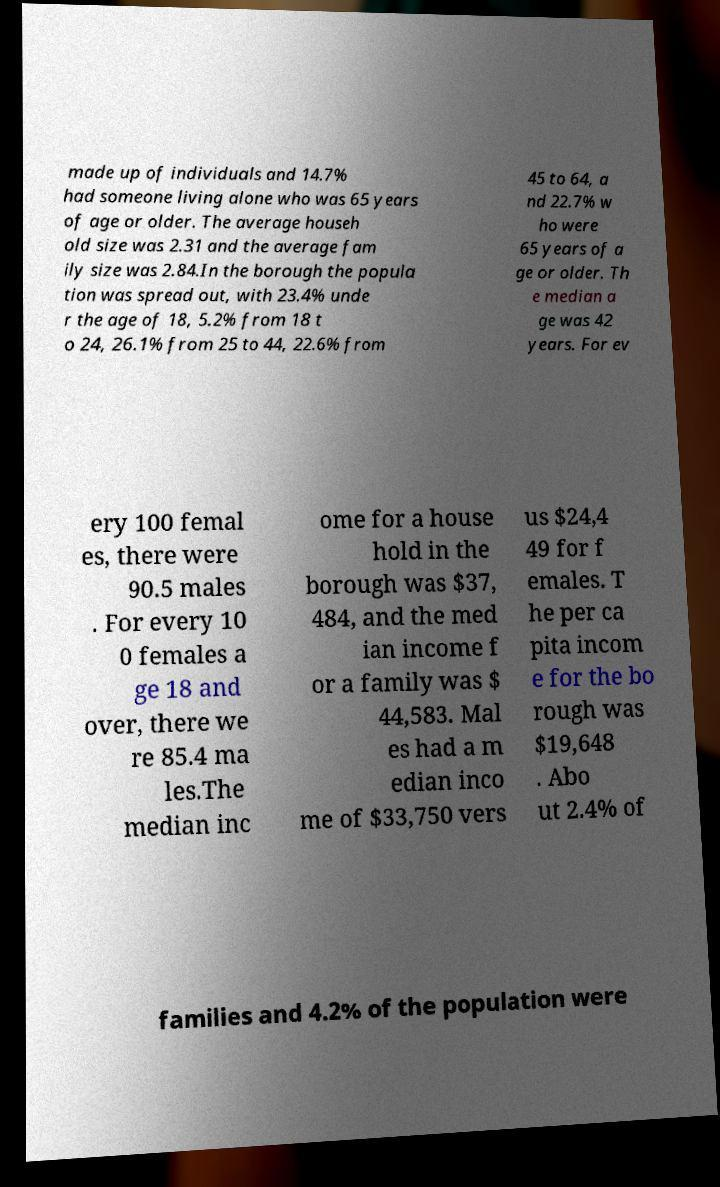Can you read and provide the text displayed in the image?This photo seems to have some interesting text. Can you extract and type it out for me? made up of individuals and 14.7% had someone living alone who was 65 years of age or older. The average househ old size was 2.31 and the average fam ily size was 2.84.In the borough the popula tion was spread out, with 23.4% unde r the age of 18, 5.2% from 18 t o 24, 26.1% from 25 to 44, 22.6% from 45 to 64, a nd 22.7% w ho were 65 years of a ge or older. Th e median a ge was 42 years. For ev ery 100 femal es, there were 90.5 males . For every 10 0 females a ge 18 and over, there we re 85.4 ma les.The median inc ome for a house hold in the borough was $37, 484, and the med ian income f or a family was $ 44,583. Mal es had a m edian inco me of $33,750 vers us $24,4 49 for f emales. T he per ca pita incom e for the bo rough was $19,648 . Abo ut 2.4% of families and 4.2% of the population were 